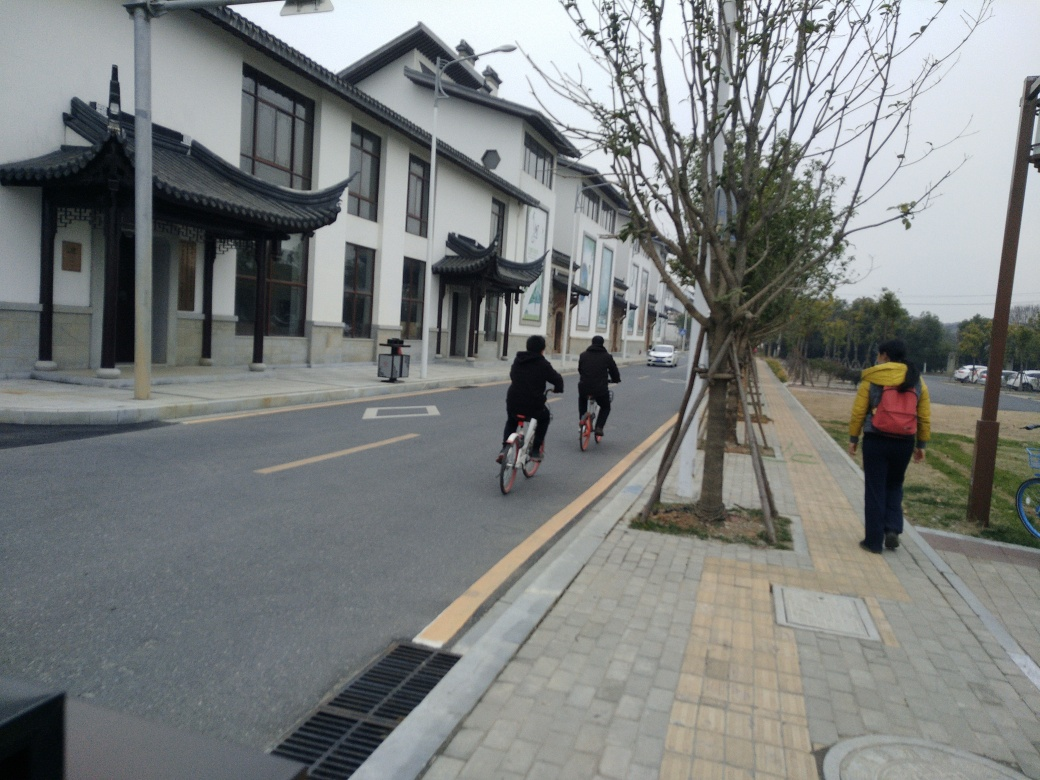What time of day does this photo seem to have been taken? The photo appears to have been taken on a cloudy day, and the absence of strong shadows suggests it could be midday when the sun is high, causing diffuse light, or it could be late afternoon on an overcast day. Are there any notable architectural styles or details visible? Yes, the buildings display traditional East Asian architectural elements, such as sweeping rooflines with upturned eaves and white-painted walls, which are indicative of historic styles often found in regions such as China or Japan. 